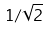<formula> <loc_0><loc_0><loc_500><loc_500>1 / \sqrt { 2 }</formula> 